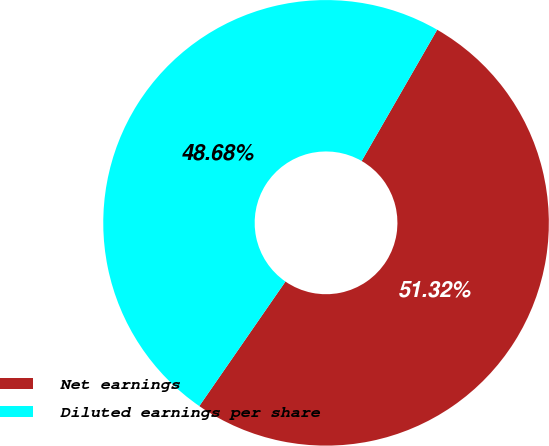Convert chart. <chart><loc_0><loc_0><loc_500><loc_500><pie_chart><fcel>Net earnings<fcel>Diluted earnings per share<nl><fcel>51.32%<fcel>48.68%<nl></chart> 